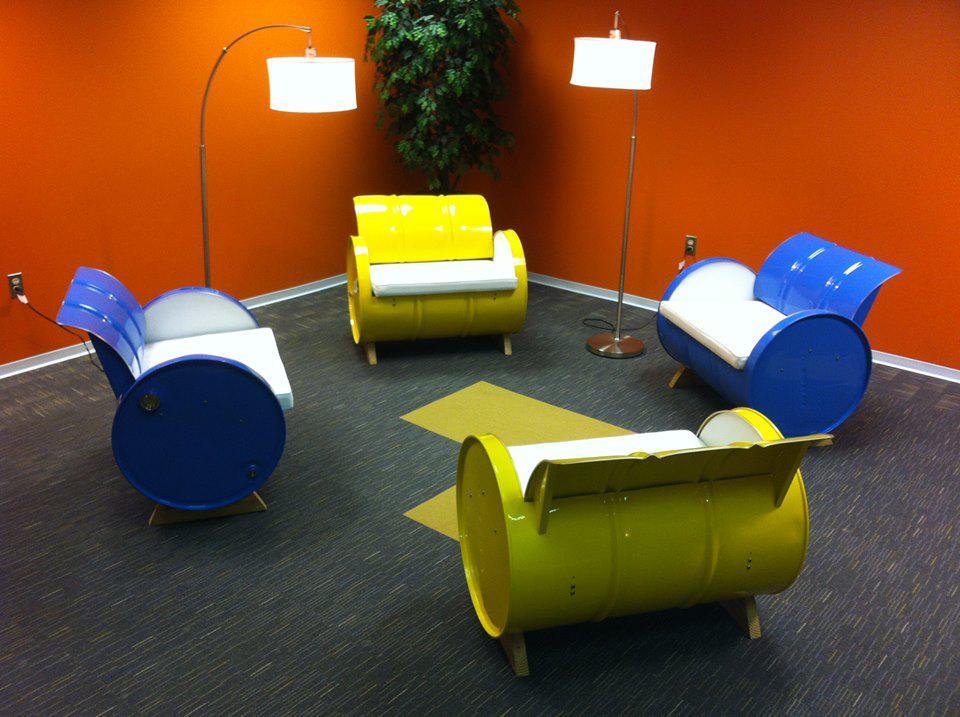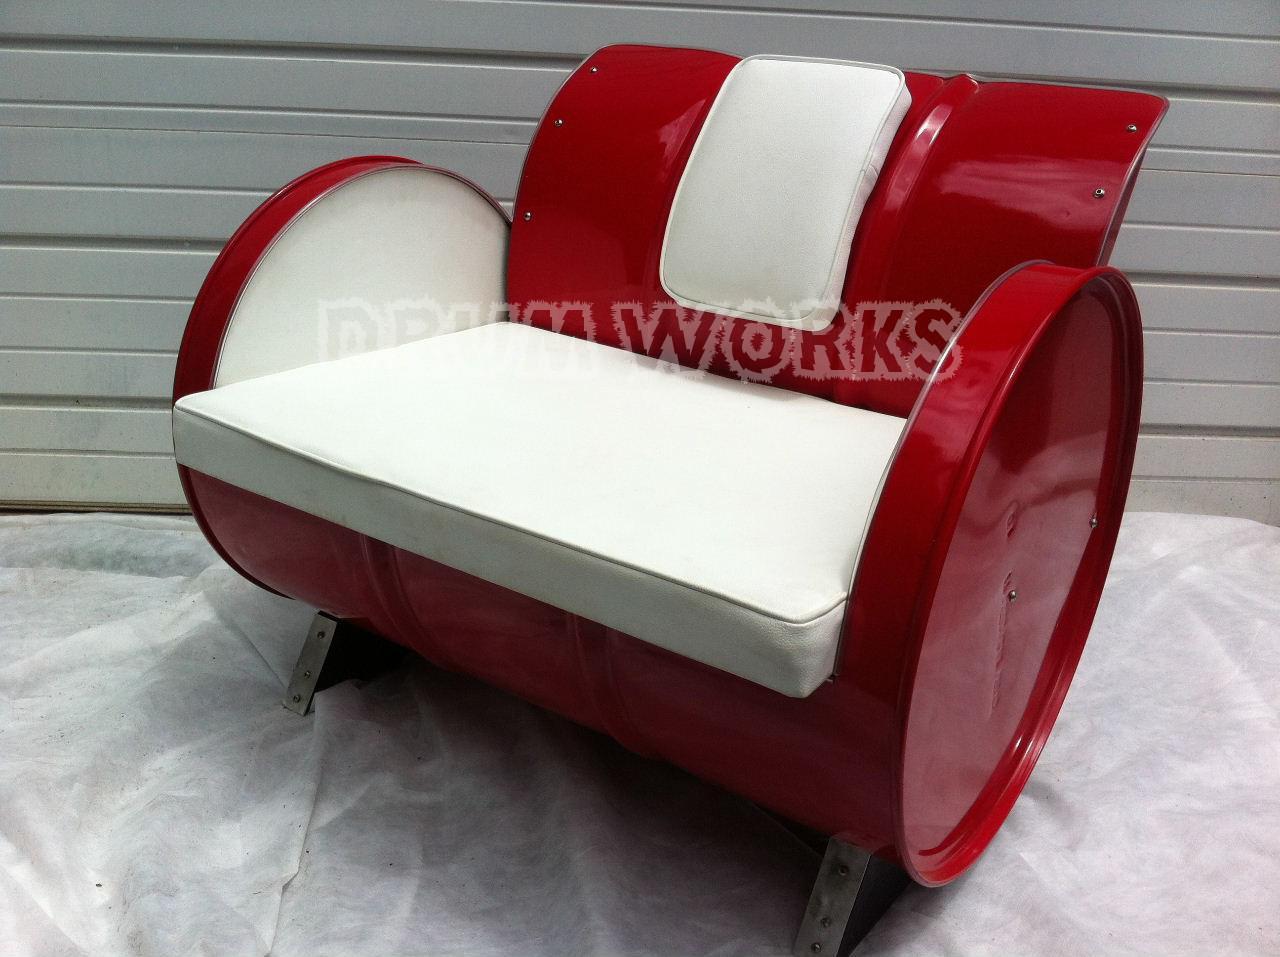The first image is the image on the left, the second image is the image on the right. Evaluate the accuracy of this statement regarding the images: "There are at least three chairs that are cushioned.". Is it true? Answer yes or no. Yes. The first image is the image on the left, the second image is the image on the right. Given the left and right images, does the statement "The combined images contain two red barrels that have been turned into seats, with the barrel on stands on its side." hold true? Answer yes or no. No. 